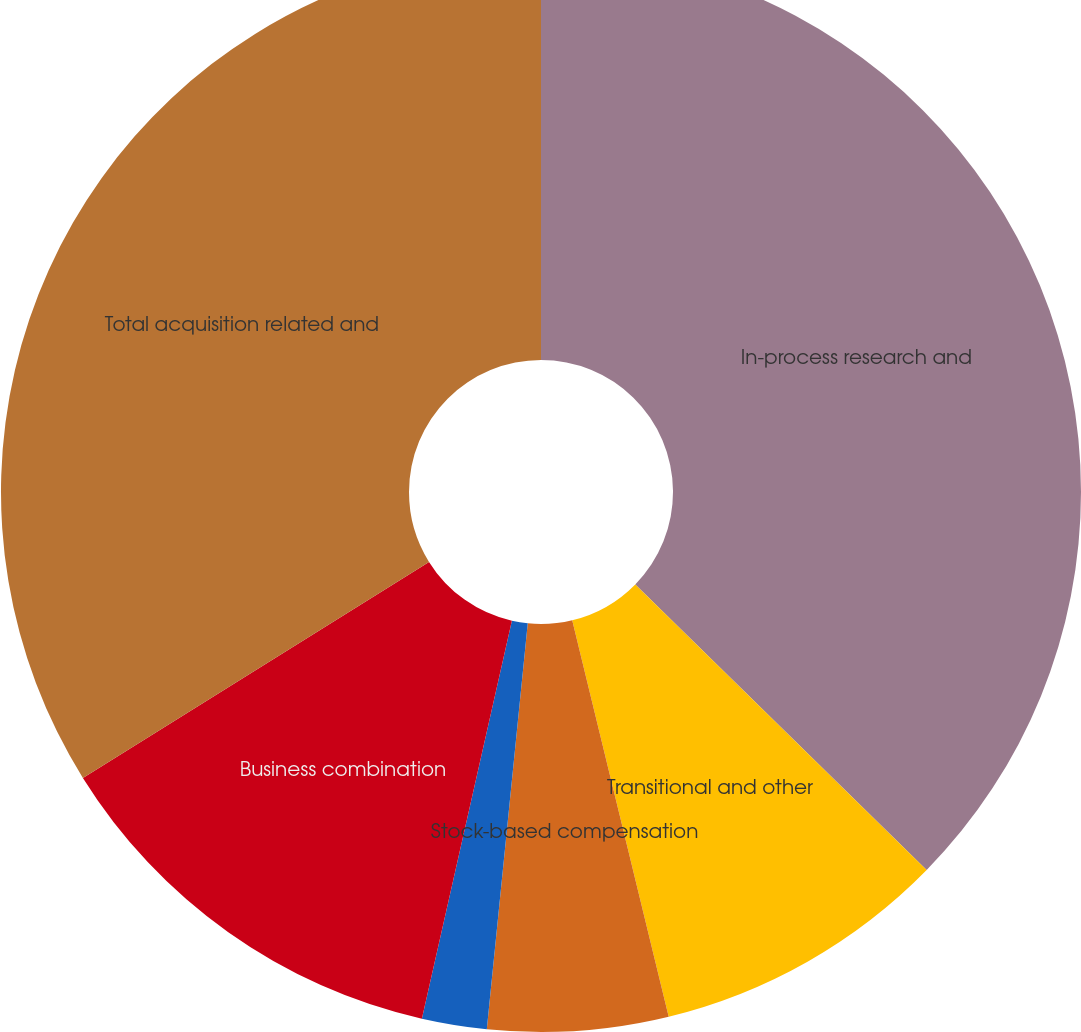<chart> <loc_0><loc_0><loc_500><loc_500><pie_chart><fcel>In-process research and<fcel>Transitional and other<fcel>Stock-based compensation<fcel>Professional fees and other<fcel>Business combination<fcel>Total acquisition related and<nl><fcel>37.34%<fcel>8.86%<fcel>5.4%<fcel>1.94%<fcel>12.58%<fcel>33.88%<nl></chart> 